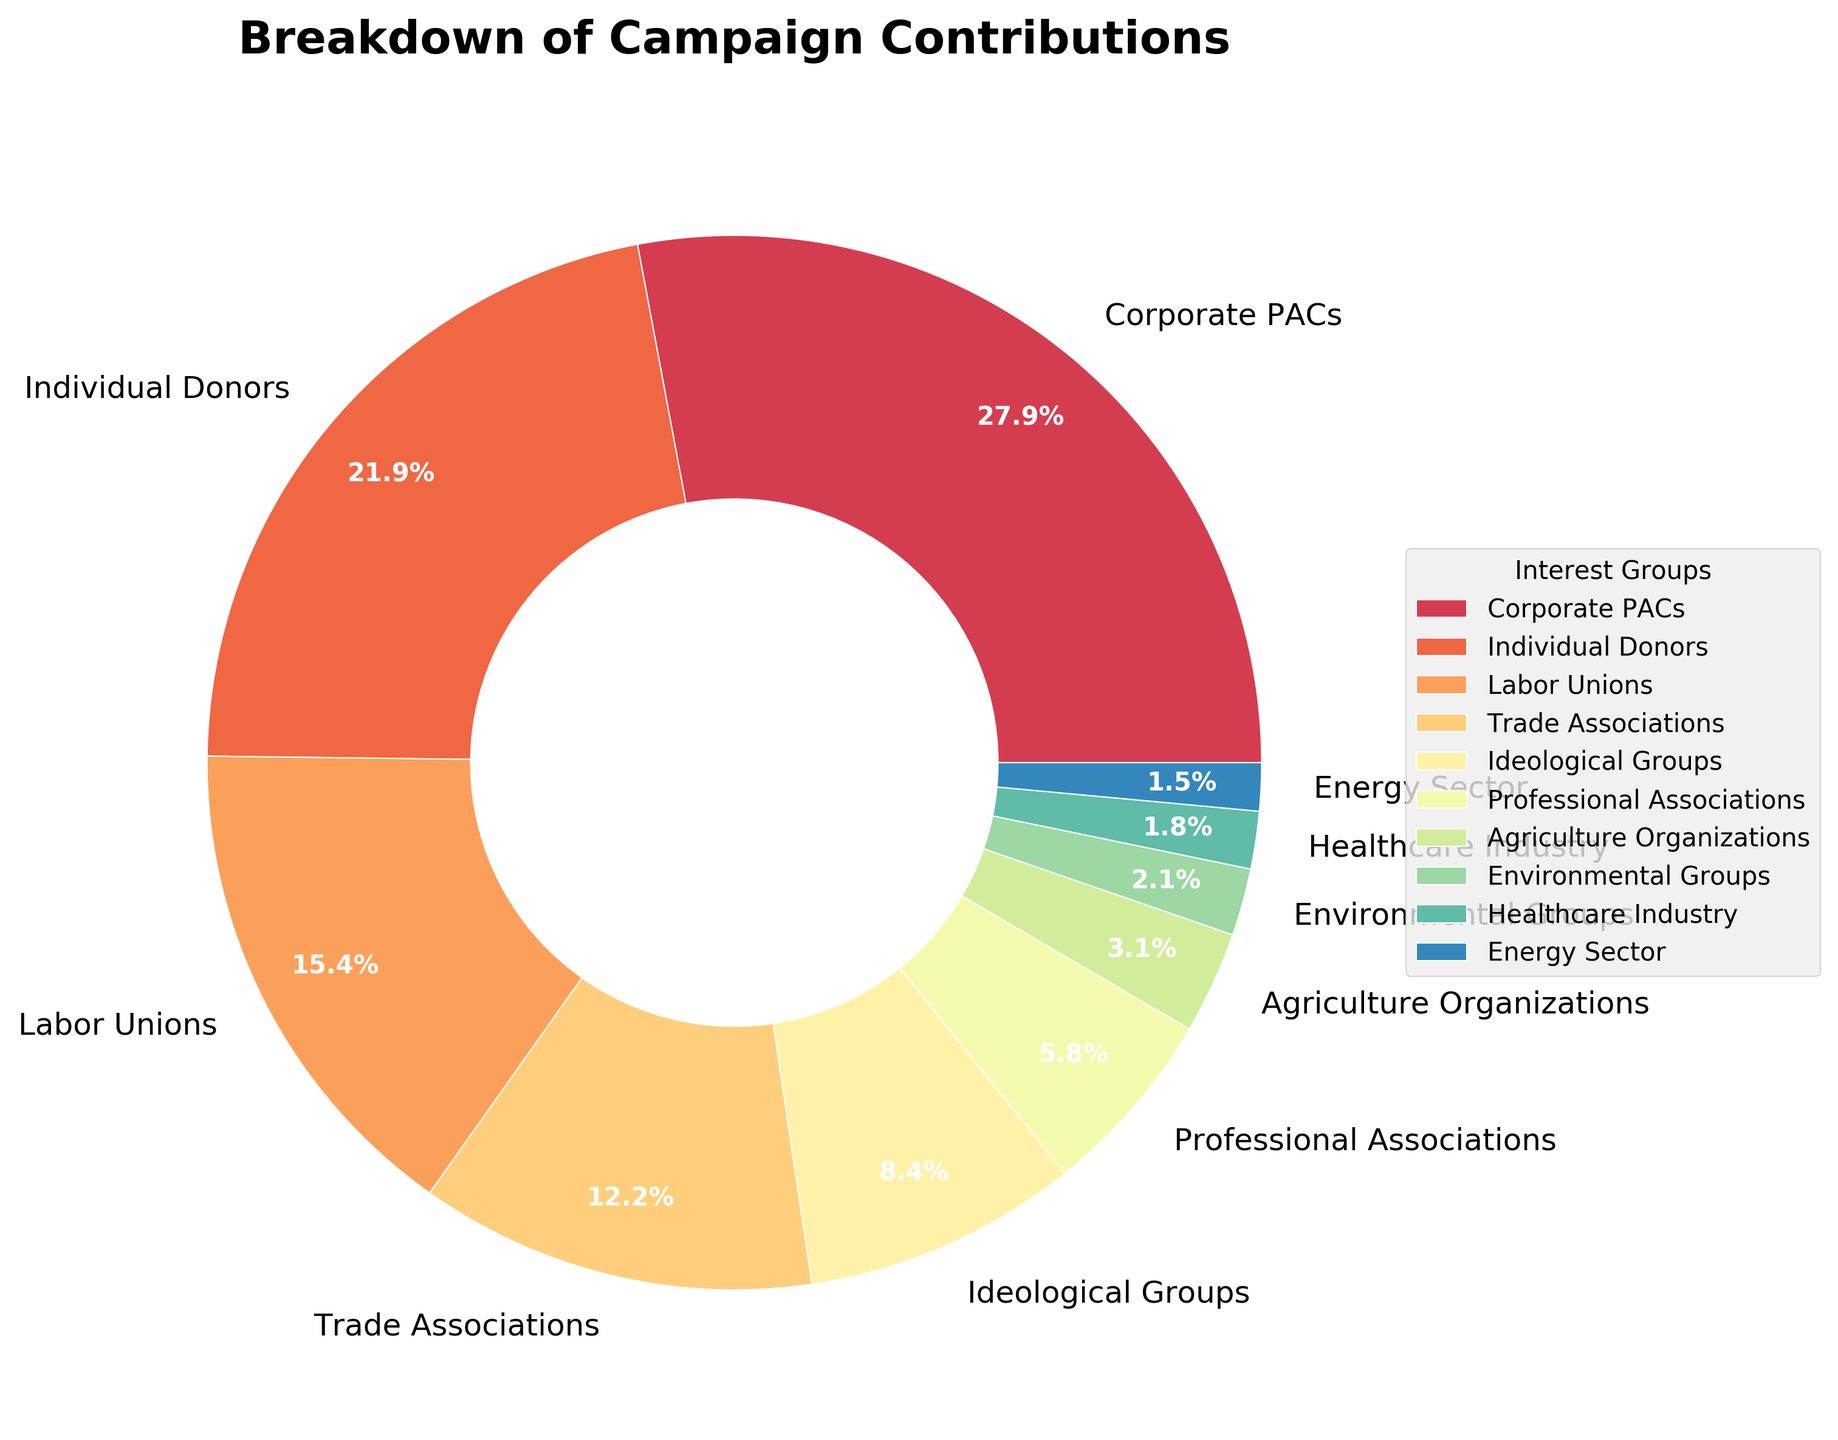What is the combined contribution percentage of Corporate PACs and Labor Unions? Add the contribution percentages for Corporate PACs (28.5%) and Labor Unions (15.7%). 28.5 + 15.7 = 44.2%
Answer: 44.2% Which interest group contributes the least to the campaign? Look at the interest group with the smallest percentage in the pie chart. The Energy Sector contributes the least with 1.5%.
Answer: Energy Sector What is the difference in contribution percentage between Individual Donors and Environmental Groups? Subtract the percentage of Environmental Groups (2.1%) from Individual Donors (22.3%). 22.3 - 2.1 = 20.2%
Answer: 20.2% Are the contributions from Corporate PACs greater than the combined contributions from Professional Associations and Agriculture Organizations? Add the percentage of Professional Associations (5.9%) and Agriculture Organizations (3.2%), then compare with Corporate PACs (28.5%). 5.9 + 3.2 = 9.1%. 28.5% is greater than 9.1%.
Answer: Yes Which interest groups have a contribution percentage greater than 10%? Identify the groups with percentages above 10%. Corporate PACs (28.5%), Individual Donors (22.3%), and Labor Unions (15.7%) meet this criterion.
Answer: Corporate PACs, Individual Donors, Labor Unions What is the average contribution percentage of Trade Associations, Ideological Groups, and Healthcare Industry? Add the percentages of Trade Associations (12.4%), Ideological Groups (8.6%), and Healthcare Industry (1.8%), then divide by 3. (12.4 + 8.6 + 1.8) / 3 = 7.6%
Answer: 7.6% What percentage of contributions come from non-labor sources (exclude Labor Unions)? Subtract the Labor Unions' contribution from the total (100%). 100% - 15.7% = 84.3%
Answer: 84.3% Which interest group representing professionals has a contribution of 5.9%? Identify the group with 5.9%. Professional Associations have a contribution of 5.9%.
Answer: Professional Associations What is the sum of contributions from Environmental Groups and Healthcare Industry? Add the percentages of Environmental Groups (2.1%) and Healthcare Industry (1.8%). 2.1 + 1.8 = 3.9%
Answer: 3.9% Which group has a larger contribution: Agriculture Organizations or Energy Sector? Compare the percentages of Agriculture Organizations (3.2%) and Energy Sector (1.5%). Agriculture Organizations have a larger contribution.
Answer: Agriculture Organizations 